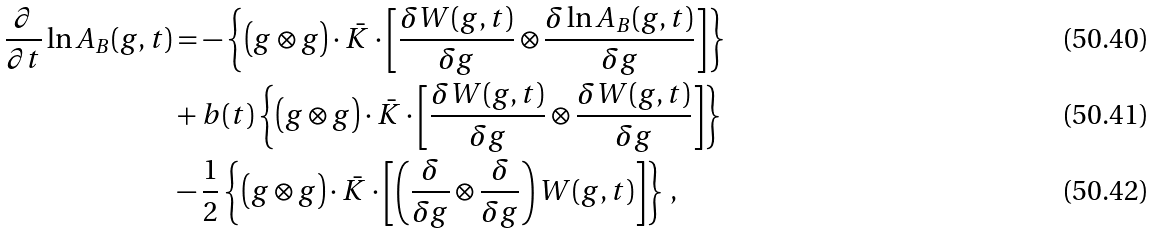<formula> <loc_0><loc_0><loc_500><loc_500>\frac { \partial } { \partial t } \ln A _ { B } ( g , t ) & = - \left \{ \left ( g \otimes g \right ) \cdot \bar { K } \cdot \left [ \frac { \delta W ( g , t ) } { \delta g } \otimes \frac { \delta \ln A _ { B } ( g , t ) } { \delta g } \right ] \right \} \\ & + b ( t ) \left \{ \left ( g \otimes g \right ) \cdot \bar { K } \cdot \left [ \frac { \delta W ( g , t ) } { \delta g } \otimes \frac { \delta W ( g , t ) } { \delta g } \right ] \right \} \\ & - \frac { 1 } { 2 } \left \{ \left ( g \otimes g \right ) \cdot \bar { K } \cdot \left [ \left ( \frac { \delta } { \delta g } \otimes \frac { \delta } { \delta g } \right ) W ( g , t ) \right ] \right \} \, ,</formula> 